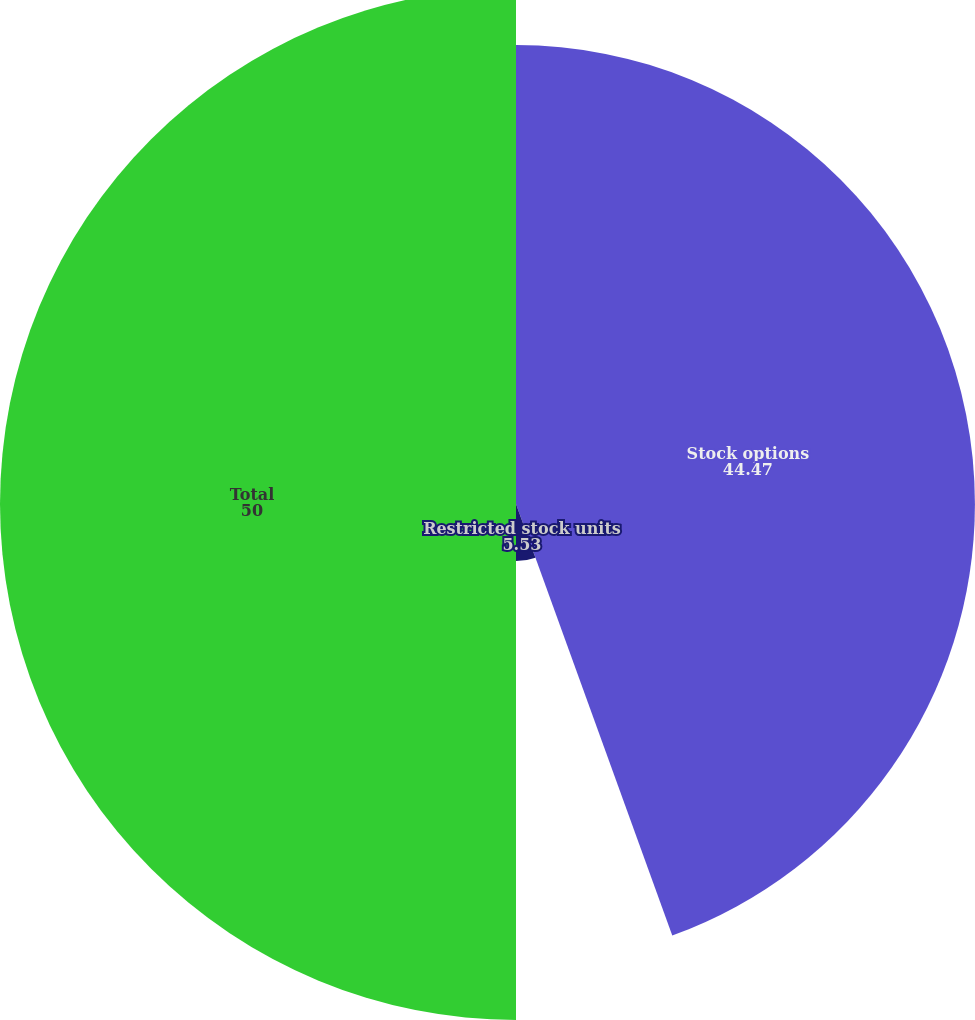<chart> <loc_0><loc_0><loc_500><loc_500><pie_chart><fcel>Stock options<fcel>Restricted stock units<fcel>Total<nl><fcel>44.47%<fcel>5.53%<fcel>50.0%<nl></chart> 